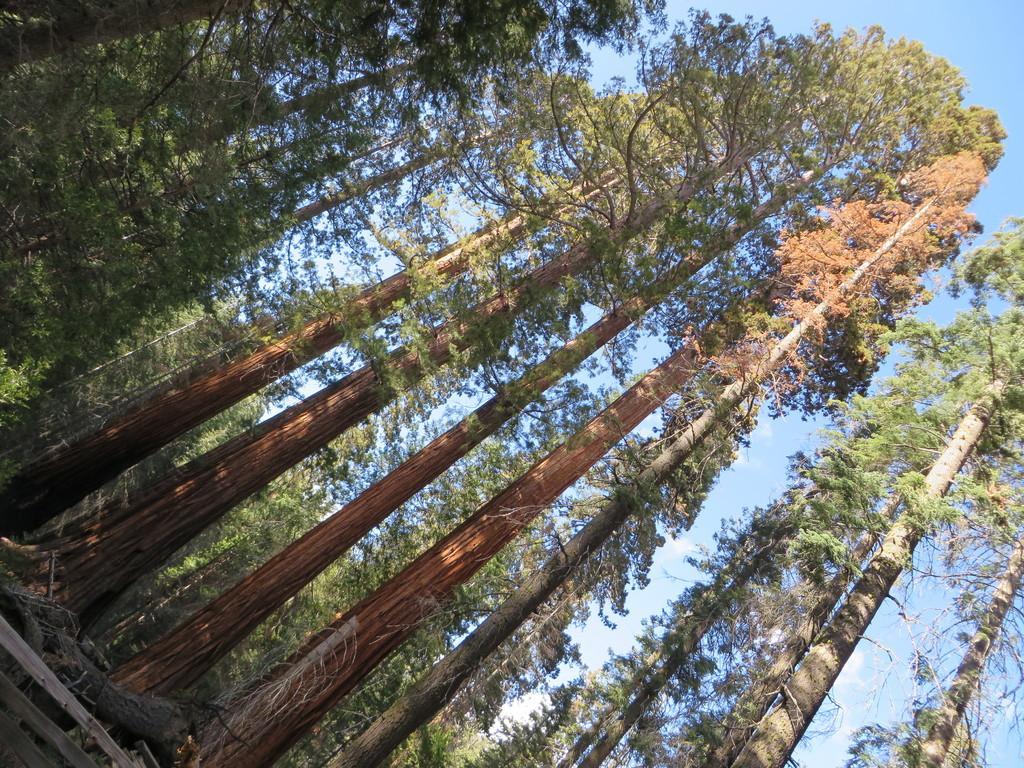Please provide a concise description of this image. In this image we can see logs and twigs on the ground, trees and sky with clouds in the background. 